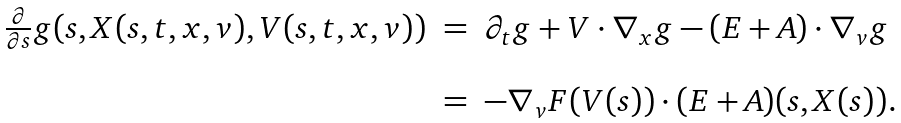<formula> <loc_0><loc_0><loc_500><loc_500>\begin{array} { r c l } \frac { \partial } { \partial s } g ( s , X ( s , t , x , v ) , V ( s , t , x , v ) ) & = & \partial _ { t } g + V \cdot \nabla _ { x } g - ( E + A ) \cdot \nabla _ { v } g \\ \\ & = & - \nabla _ { v } F ( V ( s ) ) \cdot ( E + A ) ( s , X ( s ) ) . \end{array}</formula> 